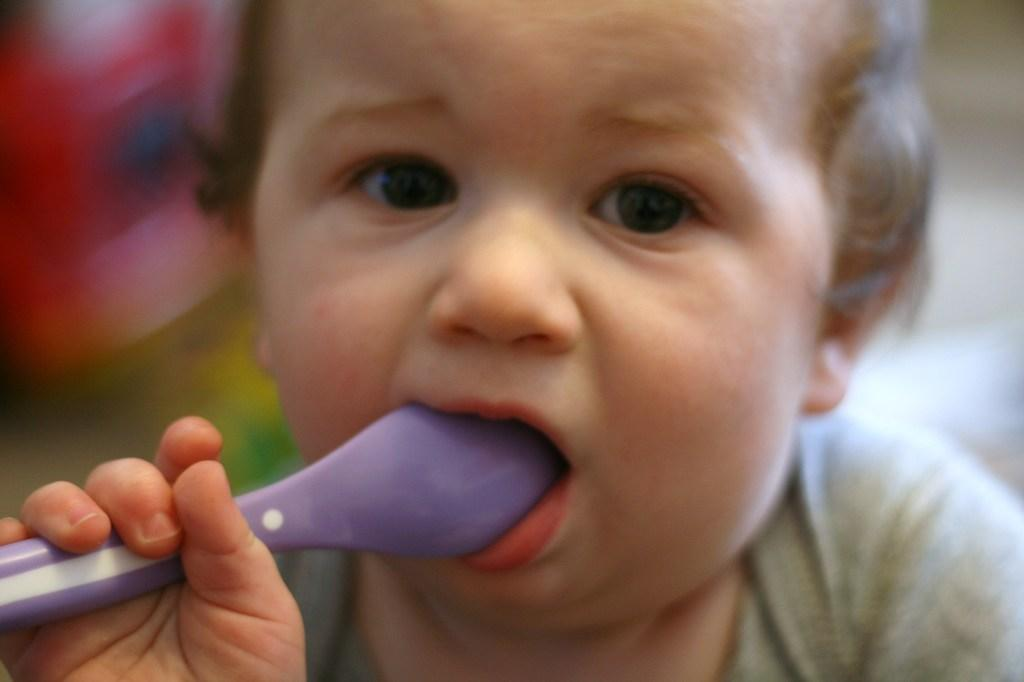What is the main subject of the picture? The main subject of the picture is a child. What is the child holding in the picture? The child is holding a spoon. Can you describe the background of the image? The background of the image is blurry. What is the child's wealth in the image? There is no information about the child's wealth in the image. --- Facts: 1. There is a car in the image. 2. The car is red. 3. The car has four wheels. 4. The car is parked on the street. Absurd Topics: bicycle Conversation: What is the main subject of the image? The main subject of the image is a car. Can you describe the car in the image? Yes, the car is red and has four wheels. Where is the car located in the image? The car is parked on the street. Reasoning: Let's think step by step in order to produce the conversation. We start by identifying the main subject of the image, which is the car. Next, we describe specific features of the car, such as its color and the number of wheels it has. Then, we observe the location of the car in the image, noting that it is parked on the street. Each question is designed to elicit a specific detail about the image that is known from the provided facts. Absurd Question/Answer: How many bicycles can be seen in the image? There are no bicycles present in the image. --- Facts: 1. There is a group of people in the image. 2. The people are wearing hats. 33. The people are holding hands. 4. The people are standing in front of a building. Absurd Topics: animals Conversation: How many people are in the image? There is a group of people in the image. Can you describe what the people are wearing in the image? Yes, the people are wearing hats. What are the people doing in the image? The people are holding hands. Can you describe the background of the image? The people are standing in front of a building. Reasoning: Let's think step by step in order to produce the conversation. We start by identifying the main subject of the image, which is the group of people. Next, we describe what the people are wearing in the image, noting that they are wearing hats. Then, we observe the actions of the people in the image, noting that they are holding hands. Finally, we describe the background of the image, noting that the people are standing in front of a building. Each question is designed to elicit a specific detail about the image that is known from the provided facts. Absurd Question/Answer: Can you see any animals in the image? There are no animals present in the image. --- Facts: 1. There 